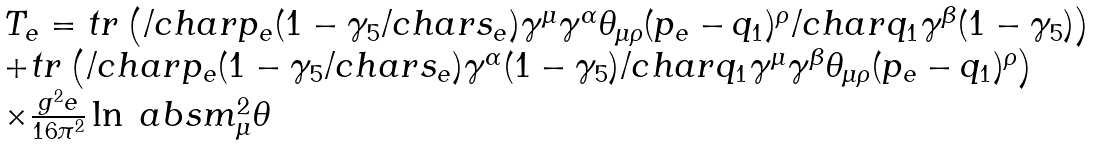Convert formula to latex. <formula><loc_0><loc_0><loc_500><loc_500>\begin{array} { l } T _ { e } = t r \left ( \slash c h a r { p _ { e } } ( 1 - \gamma _ { 5 } \slash c h a r { s _ { e } } ) \gamma ^ { \mu } \gamma ^ { \alpha } \theta _ { \mu \rho } ( p _ { e } - q _ { 1 } ) ^ { \rho } \slash c h a r { q _ { 1 } } \gamma ^ { \beta } ( 1 - \gamma _ { 5 } ) \right ) \\ + t r \left ( \slash c h a r { p _ { e } } ( 1 - \gamma _ { 5 } \slash c h a r { s _ { e } } ) \gamma ^ { \alpha } ( 1 - \gamma _ { 5 } ) \slash c h a r { q _ { 1 } } \gamma ^ { \mu } \gamma ^ { \beta } \theta _ { \mu \rho } ( p _ { e } - q _ { 1 } ) ^ { \rho } \right ) \\ \times \frac { g ^ { 2 } e } { 1 6 \pi ^ { 2 } } \ln \ a b s { m _ { \mu } ^ { 2 } \theta } \end{array}</formula> 